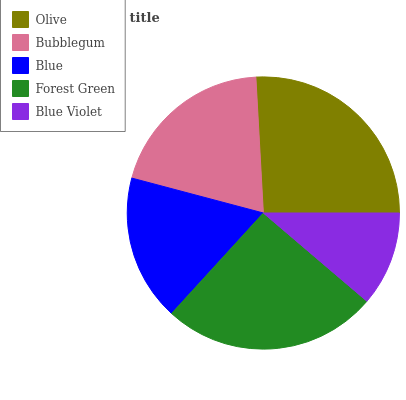Is Blue Violet the minimum?
Answer yes or no. Yes. Is Olive the maximum?
Answer yes or no. Yes. Is Bubblegum the minimum?
Answer yes or no. No. Is Bubblegum the maximum?
Answer yes or no. No. Is Olive greater than Bubblegum?
Answer yes or no. Yes. Is Bubblegum less than Olive?
Answer yes or no. Yes. Is Bubblegum greater than Olive?
Answer yes or no. No. Is Olive less than Bubblegum?
Answer yes or no. No. Is Bubblegum the high median?
Answer yes or no. Yes. Is Bubblegum the low median?
Answer yes or no. Yes. Is Forest Green the high median?
Answer yes or no. No. Is Forest Green the low median?
Answer yes or no. No. 